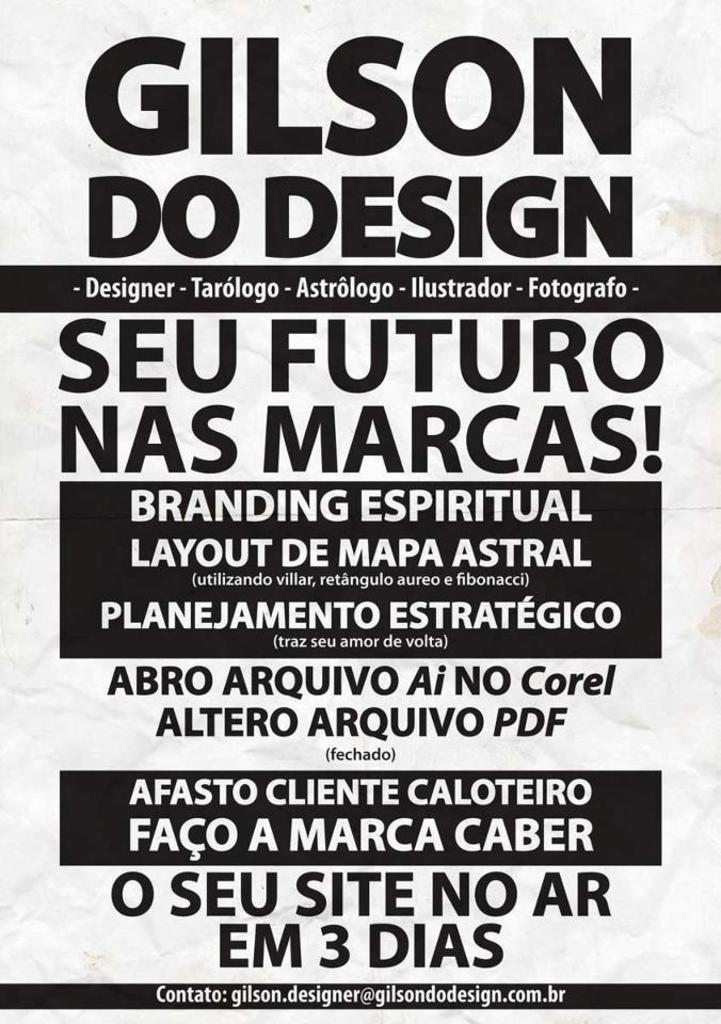Can you describe this image briefly? In this picture, we see a poster in white color with some text written in black color. 